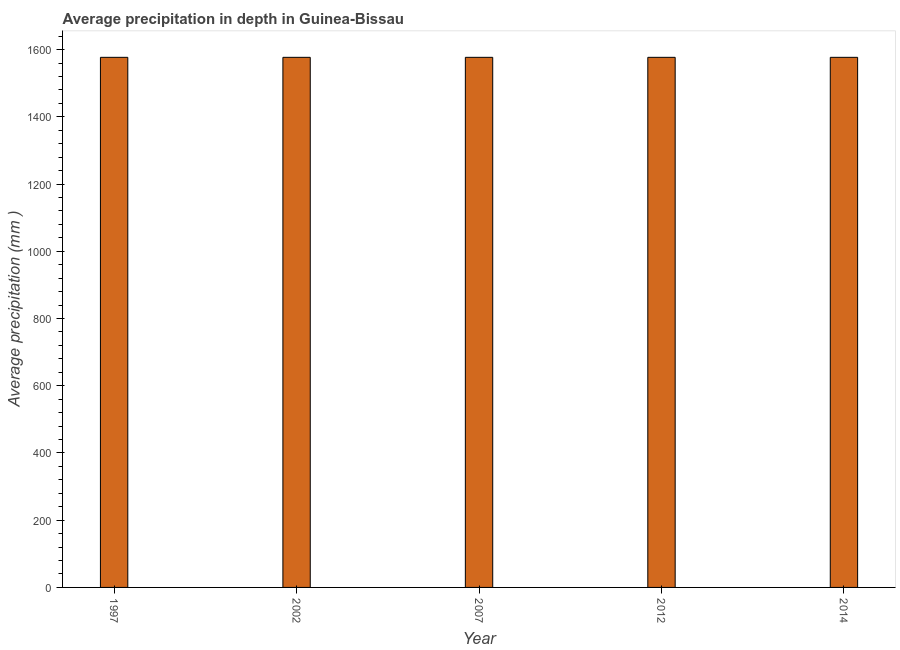Does the graph contain any zero values?
Your answer should be very brief. No. What is the title of the graph?
Give a very brief answer. Average precipitation in depth in Guinea-Bissau. What is the label or title of the Y-axis?
Your response must be concise. Average precipitation (mm ). What is the average precipitation in depth in 2012?
Your answer should be very brief. 1577. Across all years, what is the maximum average precipitation in depth?
Make the answer very short. 1577. Across all years, what is the minimum average precipitation in depth?
Your answer should be very brief. 1577. In which year was the average precipitation in depth maximum?
Offer a very short reply. 1997. What is the sum of the average precipitation in depth?
Provide a succinct answer. 7885. What is the average average precipitation in depth per year?
Your response must be concise. 1577. What is the median average precipitation in depth?
Give a very brief answer. 1577. In how many years, is the average precipitation in depth greater than 80 mm?
Your answer should be compact. 5. Do a majority of the years between 2014 and 2012 (inclusive) have average precipitation in depth greater than 1480 mm?
Provide a succinct answer. No. What is the ratio of the average precipitation in depth in 2007 to that in 2012?
Ensure brevity in your answer.  1. Is the average precipitation in depth in 2012 less than that in 2014?
Provide a short and direct response. No. Is the difference between the average precipitation in depth in 2002 and 2007 greater than the difference between any two years?
Make the answer very short. Yes. What is the difference between the highest and the second highest average precipitation in depth?
Ensure brevity in your answer.  0. Is the sum of the average precipitation in depth in 2007 and 2014 greater than the maximum average precipitation in depth across all years?
Ensure brevity in your answer.  Yes. In how many years, is the average precipitation in depth greater than the average average precipitation in depth taken over all years?
Provide a succinct answer. 0. How many bars are there?
Offer a terse response. 5. How many years are there in the graph?
Ensure brevity in your answer.  5. What is the difference between two consecutive major ticks on the Y-axis?
Give a very brief answer. 200. What is the Average precipitation (mm ) in 1997?
Ensure brevity in your answer.  1577. What is the Average precipitation (mm ) of 2002?
Give a very brief answer. 1577. What is the Average precipitation (mm ) of 2007?
Give a very brief answer. 1577. What is the Average precipitation (mm ) of 2012?
Give a very brief answer. 1577. What is the Average precipitation (mm ) of 2014?
Your response must be concise. 1577. What is the difference between the Average precipitation (mm ) in 1997 and 2002?
Keep it short and to the point. 0. What is the difference between the Average precipitation (mm ) in 1997 and 2012?
Your answer should be compact. 0. What is the difference between the Average precipitation (mm ) in 2012 and 2014?
Your answer should be very brief. 0. What is the ratio of the Average precipitation (mm ) in 1997 to that in 2002?
Make the answer very short. 1. What is the ratio of the Average precipitation (mm ) in 2002 to that in 2007?
Provide a short and direct response. 1. What is the ratio of the Average precipitation (mm ) in 2002 to that in 2012?
Make the answer very short. 1. What is the ratio of the Average precipitation (mm ) in 2007 to that in 2012?
Offer a very short reply. 1. 